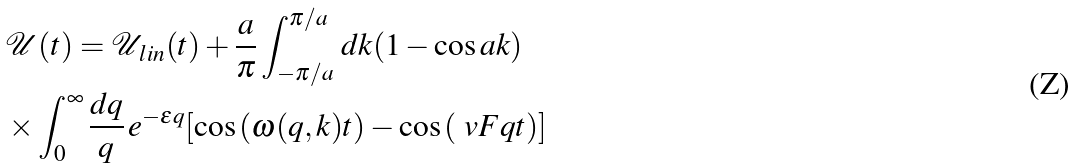<formula> <loc_0><loc_0><loc_500><loc_500>& \mathcal { U } ( t ) = \mathcal { U } _ { \, l i n } ( t ) + \frac { a } { \pi } \int _ { - \pi / a } ^ { \pi / a } \, d k ( 1 - \cos { a k } ) \\ & \times \int _ { 0 } ^ { \infty } \frac { d q } { q } \, e ^ { - \epsilon q } [ \cos { ( \omega ( q , k ) t } ) - \cos { ( \ v F q t ) } ]</formula> 